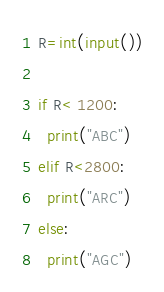<code> <loc_0><loc_0><loc_500><loc_500><_Python_>R=int(input())

if R< 1200:
  print("ABC")
elif R<2800:
  print("ARC")
else:
  print("AGC")
</code> 